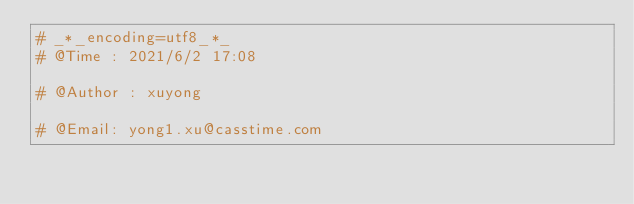Convert code to text. <code><loc_0><loc_0><loc_500><loc_500><_Python_># _*_encoding=utf8_*_
# @Time : 2021/6/2 17:08 

# @Author : xuyong

# @Email: yong1.xu@casstime.com</code> 